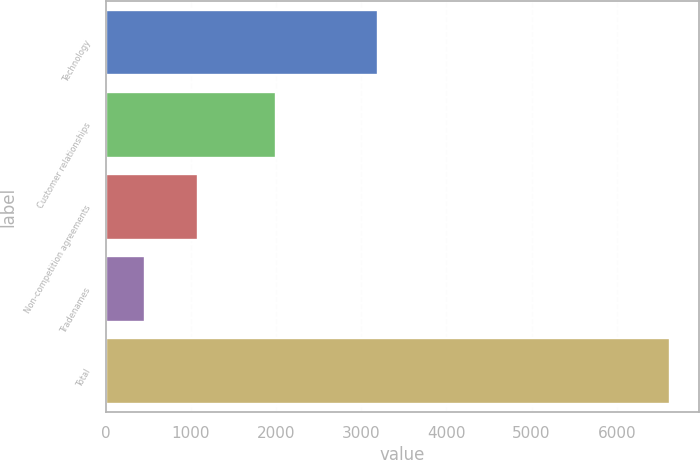Convert chart. <chart><loc_0><loc_0><loc_500><loc_500><bar_chart><fcel>Technology<fcel>Customer relationships<fcel>Non-competition agreements<fcel>Tradenames<fcel>Total<nl><fcel>3202<fcel>1999<fcel>1083.3<fcel>467<fcel>6630<nl></chart> 